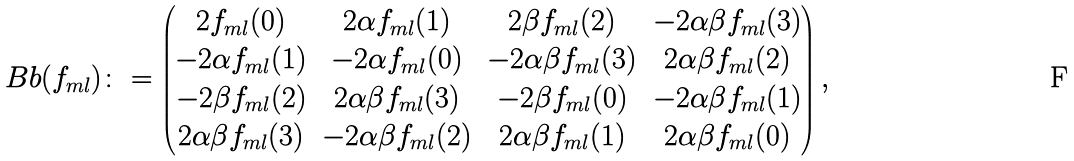Convert formula to latex. <formula><loc_0><loc_0><loc_500><loc_500>\ B b ( f _ { m l } ) \colon = \left ( \begin{matrix} 2 f _ { m l } ( 0 ) & 2 \alpha f _ { m l } ( 1 ) & 2 \beta f _ { m l } ( 2 ) & - 2 \alpha \beta f _ { m l } ( 3 ) \\ - 2 \alpha f _ { m l } ( 1 ) & - 2 \alpha f _ { m l } ( 0 ) & - 2 \alpha \beta f _ { m l } ( 3 ) & 2 \alpha \beta f _ { m l } ( 2 ) \\ - 2 \beta f _ { m l } ( 2 ) & 2 \alpha \beta f _ { m l } ( 3 ) & - 2 \beta f _ { m l } ( 0 ) & - 2 \alpha \beta f _ { m l } ( 1 ) \\ 2 \alpha \beta f _ { m l } ( 3 ) & - 2 \alpha \beta f _ { m l } ( 2 ) & 2 \alpha \beta f _ { m l } ( 1 ) & 2 \alpha \beta f _ { m l } ( 0 ) \end{matrix} \right ) ,</formula> 